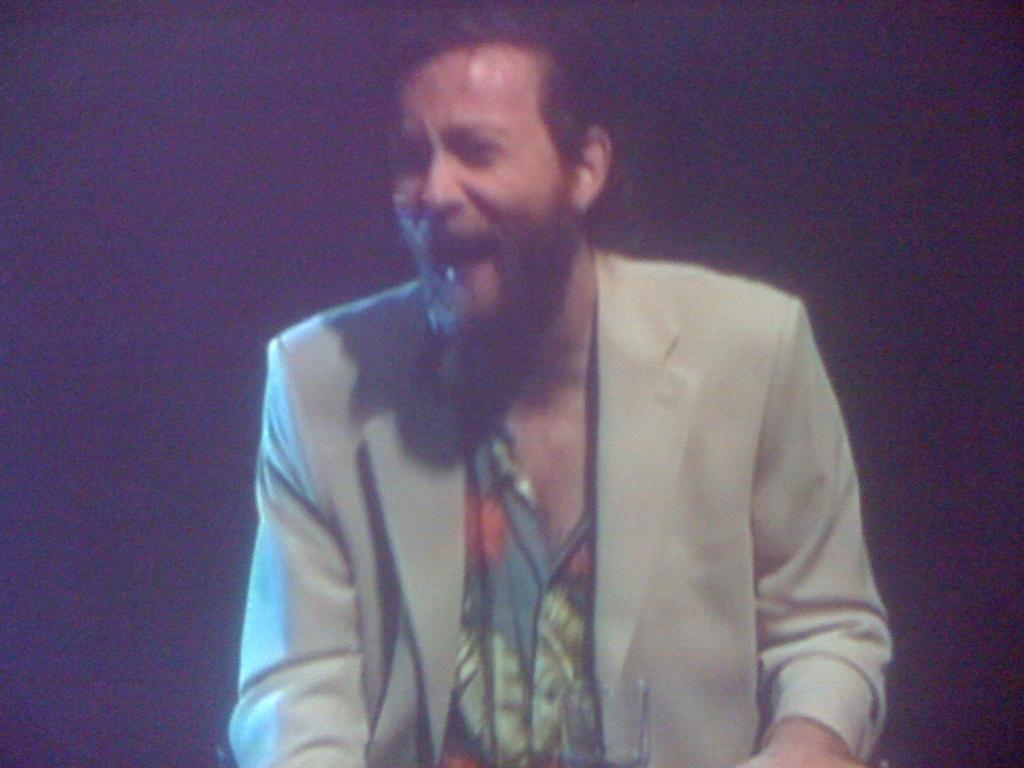What is present in the image? There is a person in the image. Can you describe the person's expression? The person is smiling. What type of blade is the person holding in the image? There is no blade present in the image; the person is simply smiling. 